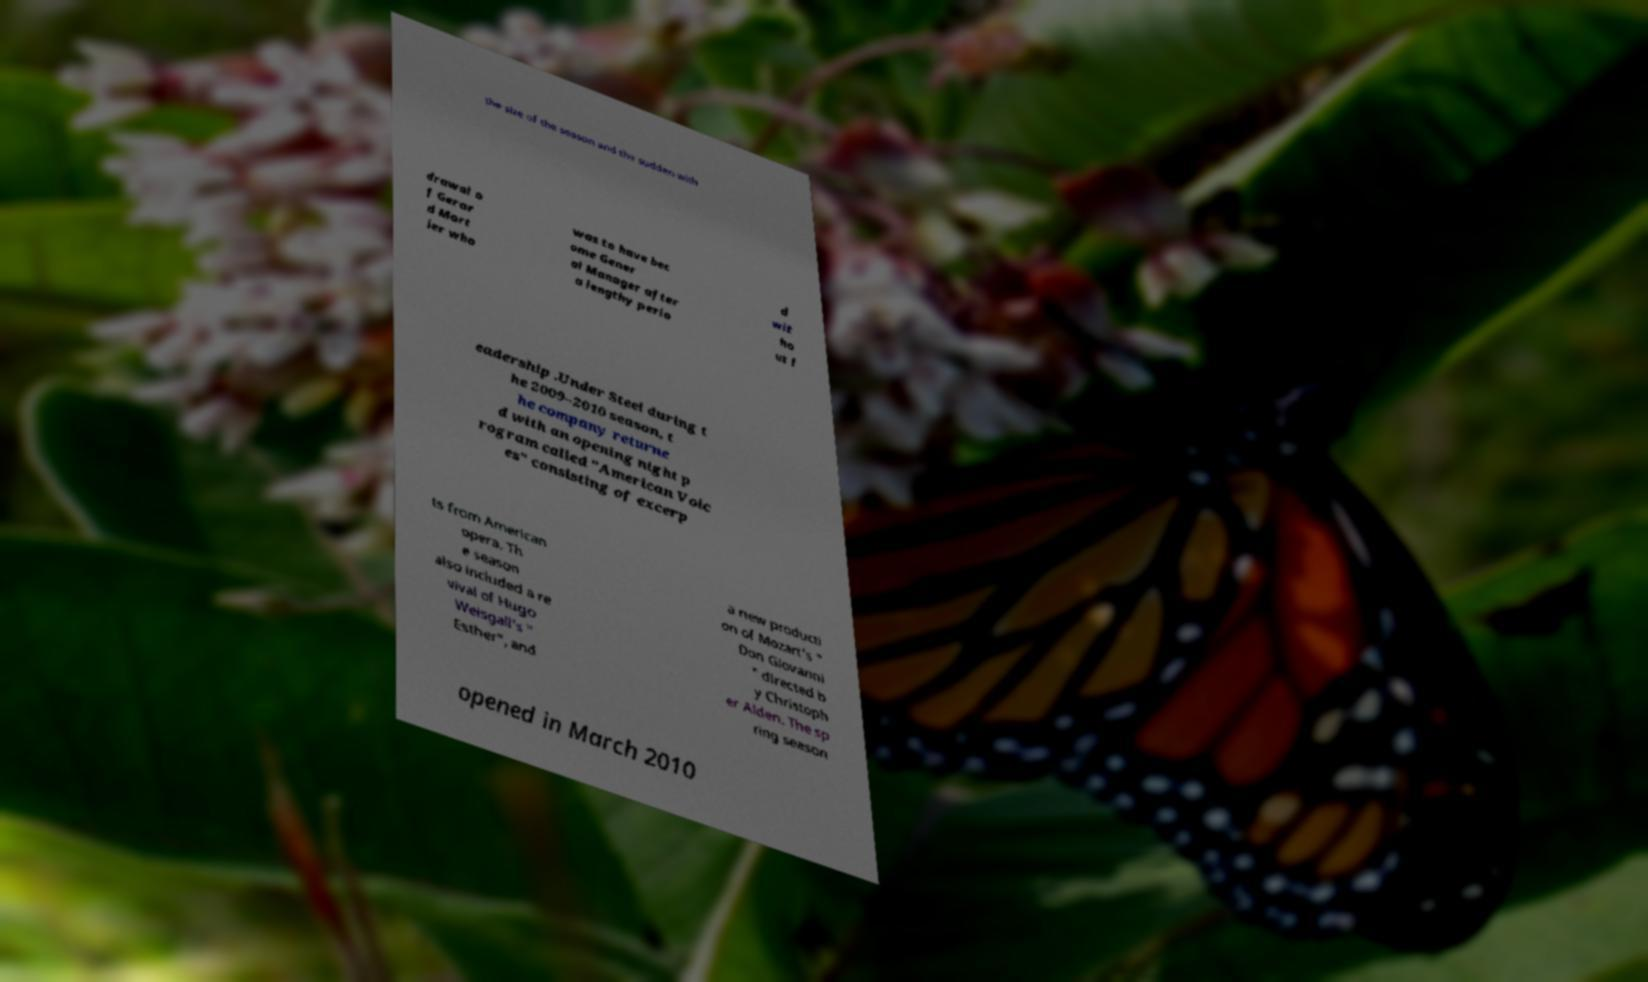Please identify and transcribe the text found in this image. the size of the season and the sudden with drawal o f Gerar d Mort ier who was to have bec ome Gener al Manager after a lengthy perio d wit ho ut l eadership .Under Steel during t he 2009–2010 season, t he company returne d with an opening night p rogram called "American Voic es" consisting of excerp ts from American opera. Th e season also included a re vival of Hugo Weisgall's " Esther", and a new producti on of Mozart's " Don Giovanni " directed b y Christoph er Alden. The sp ring season opened in March 2010 